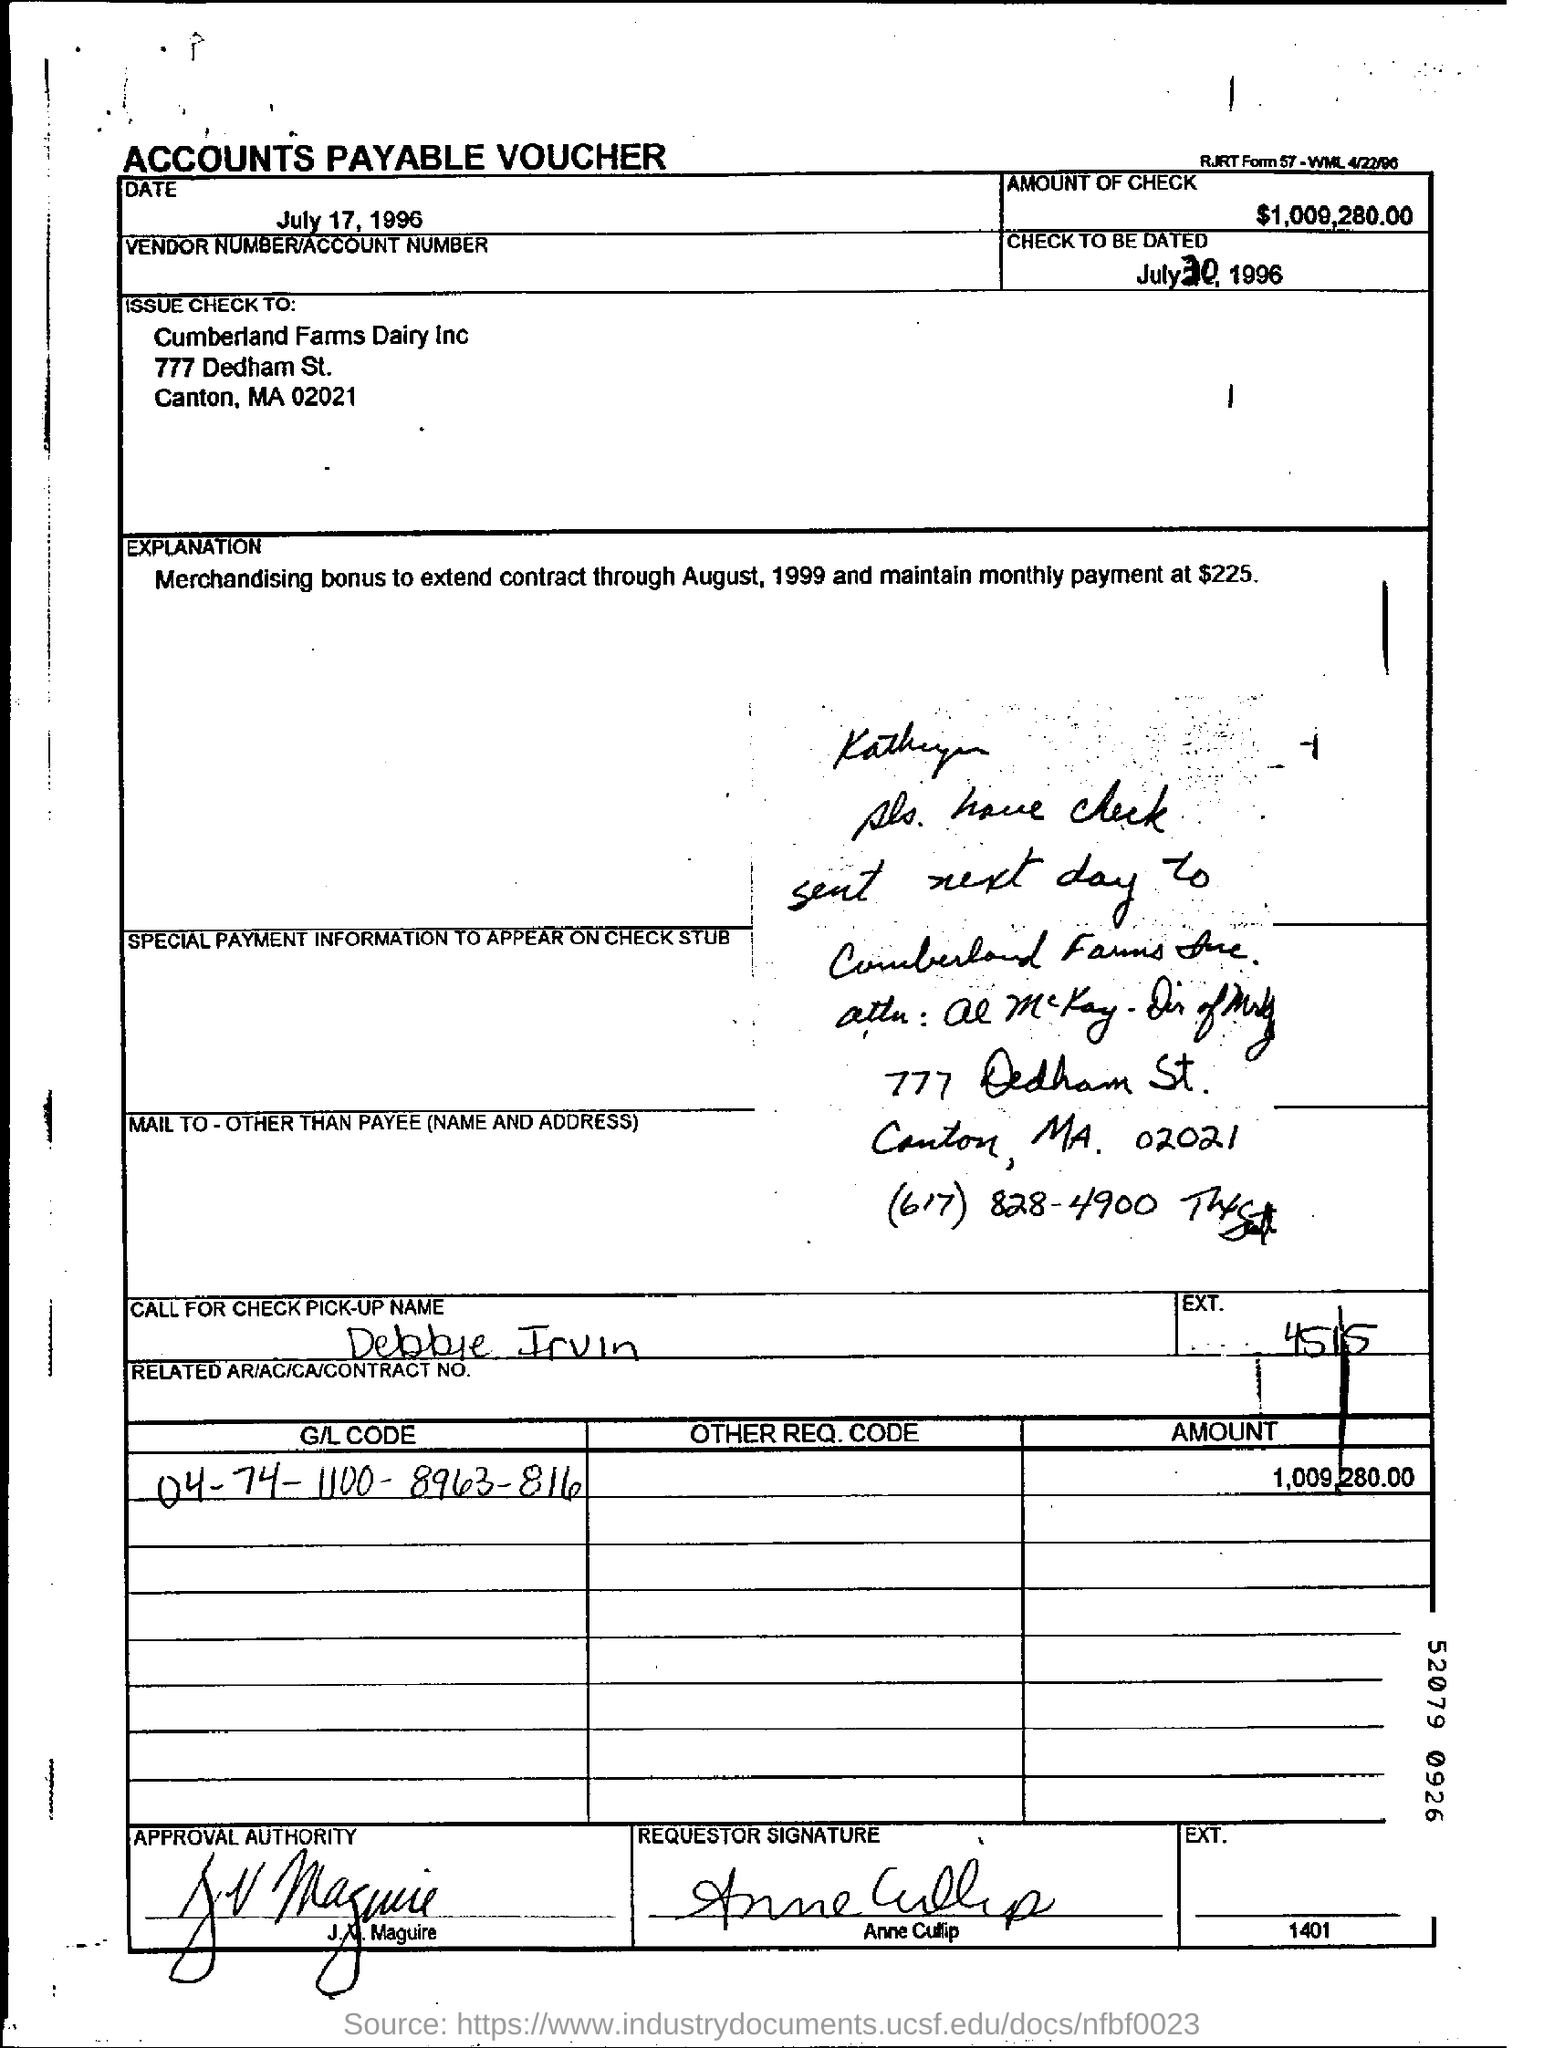Draw attention to some important aspects in this diagram. What is the check to be dated? July 30, 1996. The voucher does not provide an EXT. number. The number listed is 4515. The G/L code mentioned in the voucher is 04-74-1100-8963-816. The amount mentioned in the voucher is 1,009,280.00. The check is issued to Cumberland Farms Dairy Inc. 